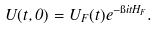<formula> <loc_0><loc_0><loc_500><loc_500>U ( t , 0 ) = U _ { F } ( t ) e ^ { - \i i t H _ { F } } .</formula> 